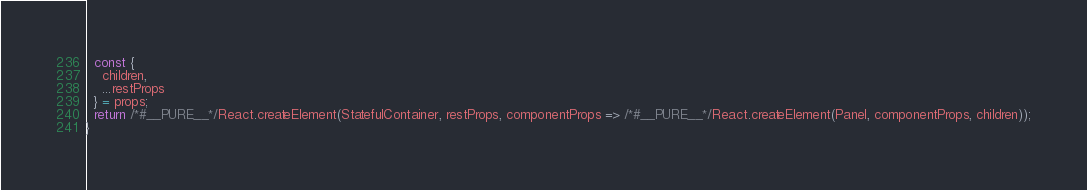Convert code to text. <code><loc_0><loc_0><loc_500><loc_500><_JavaScript_>  const {
    children,
    ...restProps
  } = props;
  return /*#__PURE__*/React.createElement(StatefulContainer, restProps, componentProps => /*#__PURE__*/React.createElement(Panel, componentProps, children));
}</code> 